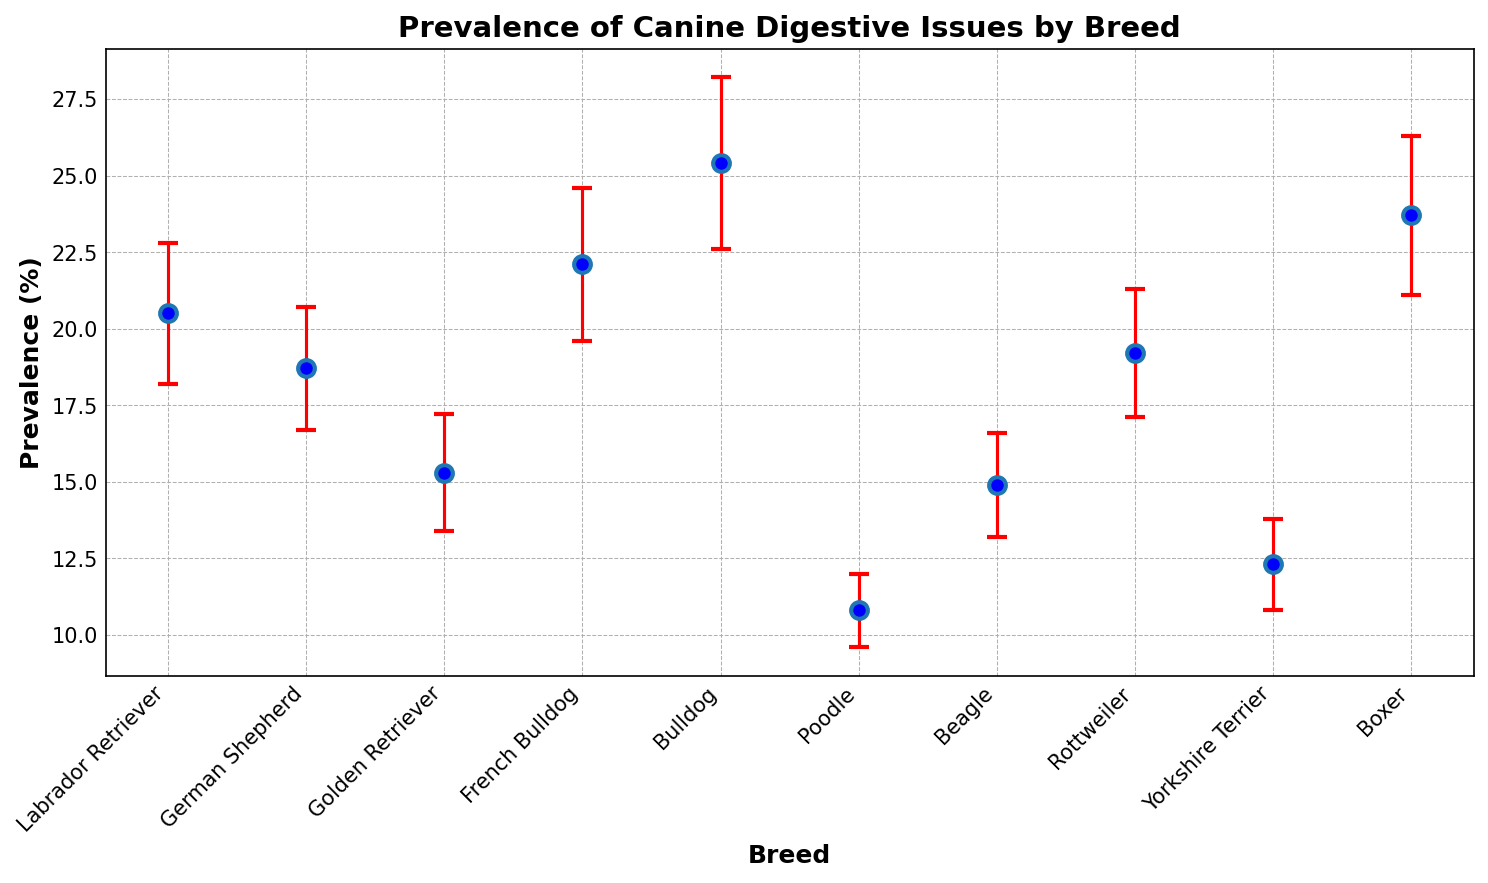What breed has the highest prevalence of digestive issues? Looking at the figure, the breed with the highest value on the y-axis represents the prevalence of digestive issues. The Bulldog has the highest prevalence at 25.4%.
Answer: Bulldog Which breed has the lowest standard deviation in the prevalence of digestive issues? To find the lowest standard deviation, examine the error bars. The Poodle has the shortest error bars, indicating a standard deviation of 1.2%.
Answer: Poodle What is the difference in prevalence between the breed with the highest and the breed with the lowest digestive issues? The Bulldog has the highest prevalence at 25.4%, and the Poodle has the lowest prevalence at 10.8%. The difference is 25.4% - 10.8% = 14.6%.
Answer: 14.6% Which two breeds have an equal prevalence of digestive issues within their standard deviation range? Check the overlap of error bars of any two breeds. The Labrador Retriever (20.5% ± 2.3%) and the German Shepherd (18.7% ± 2.0%) overlap significantly.
Answer: Labrador Retriever and German Shepherd How many breeds have a prevalence of digestive issues higher than 20%? Identify breeds with prevalence values over 20% on the y-axis: French Bulldog, Bulldog, and Boxer, making a total of three breeds.
Answer: Three breeds Which breed shows the most consistent data, indicated by the smallest error bar? Consistency is shown by small error bars. The Poodle has the smallest error bar, indicating the most consistent data with a standard deviation of 1.2%.
Answer: Poodle What is the average prevalence of digestive issues for all the breeds combined? Sum the prevalence values of all breeds and divide by the number of breeds: (20.5 + 18.7 + 15.3 + 22.1 + 25.4 + 10.8 + 14.9 + 19.2 + 12.3 + 23.7) / 10 = 18.29%.
Answer: 18.29% Which breed has a prevalence of digestive issues closest to the overall average? Calculate the average prevalence (18.29%) and compare it with each breed's prevalence. The value closest to 18.29% is that of the German Shepherd at 18.7%.
Answer: German Shepherd Identify the breed with the largest error bar and determine its implications for data consistency. The largest error bar indicates less consistent data. The Bulldog has the largest error bar with a standard deviation of 2.8%, suggesting significant variability in data.
Answer: Bulldog 